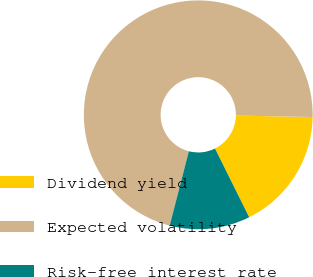Convert chart. <chart><loc_0><loc_0><loc_500><loc_500><pie_chart><fcel>Dividend yield<fcel>Expected volatility<fcel>Risk-free interest rate<nl><fcel>17.35%<fcel>71.29%<fcel>11.36%<nl></chart> 